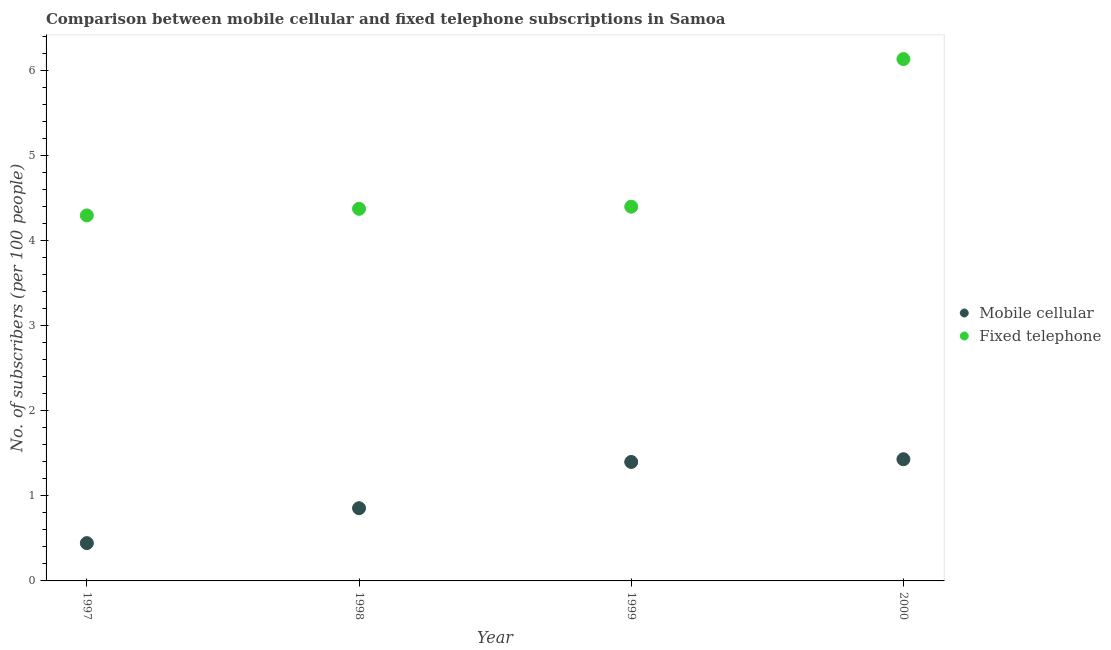What is the number of mobile cellular subscribers in 1998?
Offer a terse response. 0.86. Across all years, what is the maximum number of fixed telephone subscribers?
Your response must be concise. 6.14. Across all years, what is the minimum number of fixed telephone subscribers?
Provide a short and direct response. 4.3. What is the total number of mobile cellular subscribers in the graph?
Offer a very short reply. 4.13. What is the difference between the number of mobile cellular subscribers in 1999 and that in 2000?
Make the answer very short. -0.03. What is the difference between the number of fixed telephone subscribers in 1997 and the number of mobile cellular subscribers in 2000?
Provide a short and direct response. 2.87. What is the average number of fixed telephone subscribers per year?
Give a very brief answer. 4.81. In the year 1997, what is the difference between the number of mobile cellular subscribers and number of fixed telephone subscribers?
Offer a very short reply. -3.86. What is the ratio of the number of mobile cellular subscribers in 1997 to that in 1998?
Your response must be concise. 0.52. Is the number of fixed telephone subscribers in 1998 less than that in 1999?
Offer a very short reply. Yes. Is the difference between the number of mobile cellular subscribers in 1999 and 2000 greater than the difference between the number of fixed telephone subscribers in 1999 and 2000?
Your response must be concise. Yes. What is the difference between the highest and the second highest number of fixed telephone subscribers?
Your answer should be very brief. 1.74. What is the difference between the highest and the lowest number of mobile cellular subscribers?
Keep it short and to the point. 0.99. In how many years, is the number of mobile cellular subscribers greater than the average number of mobile cellular subscribers taken over all years?
Offer a very short reply. 2. How many dotlines are there?
Make the answer very short. 2. What is the difference between two consecutive major ticks on the Y-axis?
Make the answer very short. 1. Where does the legend appear in the graph?
Provide a short and direct response. Center right. How many legend labels are there?
Ensure brevity in your answer.  2. What is the title of the graph?
Your response must be concise. Comparison between mobile cellular and fixed telephone subscriptions in Samoa. What is the label or title of the Y-axis?
Your response must be concise. No. of subscribers (per 100 people). What is the No. of subscribers (per 100 people) of Mobile cellular in 1997?
Make the answer very short. 0.44. What is the No. of subscribers (per 100 people) in Fixed telephone in 1997?
Offer a terse response. 4.3. What is the No. of subscribers (per 100 people) in Mobile cellular in 1998?
Your response must be concise. 0.86. What is the No. of subscribers (per 100 people) of Fixed telephone in 1998?
Offer a very short reply. 4.38. What is the No. of subscribers (per 100 people) of Mobile cellular in 1999?
Your answer should be compact. 1.4. What is the No. of subscribers (per 100 people) of Fixed telephone in 1999?
Make the answer very short. 4.4. What is the No. of subscribers (per 100 people) of Mobile cellular in 2000?
Your answer should be compact. 1.43. What is the No. of subscribers (per 100 people) of Fixed telephone in 2000?
Ensure brevity in your answer.  6.14. Across all years, what is the maximum No. of subscribers (per 100 people) in Mobile cellular?
Provide a succinct answer. 1.43. Across all years, what is the maximum No. of subscribers (per 100 people) in Fixed telephone?
Give a very brief answer. 6.14. Across all years, what is the minimum No. of subscribers (per 100 people) in Mobile cellular?
Your response must be concise. 0.44. Across all years, what is the minimum No. of subscribers (per 100 people) of Fixed telephone?
Ensure brevity in your answer.  4.3. What is the total No. of subscribers (per 100 people) in Mobile cellular in the graph?
Provide a succinct answer. 4.13. What is the total No. of subscribers (per 100 people) in Fixed telephone in the graph?
Your answer should be very brief. 19.22. What is the difference between the No. of subscribers (per 100 people) in Mobile cellular in 1997 and that in 1998?
Ensure brevity in your answer.  -0.41. What is the difference between the No. of subscribers (per 100 people) in Fixed telephone in 1997 and that in 1998?
Make the answer very short. -0.08. What is the difference between the No. of subscribers (per 100 people) in Mobile cellular in 1997 and that in 1999?
Keep it short and to the point. -0.95. What is the difference between the No. of subscribers (per 100 people) in Fixed telephone in 1997 and that in 1999?
Offer a terse response. -0.1. What is the difference between the No. of subscribers (per 100 people) in Mobile cellular in 1997 and that in 2000?
Make the answer very short. -0.99. What is the difference between the No. of subscribers (per 100 people) in Fixed telephone in 1997 and that in 2000?
Provide a short and direct response. -1.84. What is the difference between the No. of subscribers (per 100 people) of Mobile cellular in 1998 and that in 1999?
Your response must be concise. -0.54. What is the difference between the No. of subscribers (per 100 people) in Fixed telephone in 1998 and that in 1999?
Offer a very short reply. -0.02. What is the difference between the No. of subscribers (per 100 people) in Mobile cellular in 1998 and that in 2000?
Give a very brief answer. -0.58. What is the difference between the No. of subscribers (per 100 people) of Fixed telephone in 1998 and that in 2000?
Keep it short and to the point. -1.76. What is the difference between the No. of subscribers (per 100 people) of Mobile cellular in 1999 and that in 2000?
Your answer should be very brief. -0.03. What is the difference between the No. of subscribers (per 100 people) of Fixed telephone in 1999 and that in 2000?
Give a very brief answer. -1.74. What is the difference between the No. of subscribers (per 100 people) of Mobile cellular in 1997 and the No. of subscribers (per 100 people) of Fixed telephone in 1998?
Your response must be concise. -3.93. What is the difference between the No. of subscribers (per 100 people) in Mobile cellular in 1997 and the No. of subscribers (per 100 people) in Fixed telephone in 1999?
Your answer should be very brief. -3.96. What is the difference between the No. of subscribers (per 100 people) in Mobile cellular in 1997 and the No. of subscribers (per 100 people) in Fixed telephone in 2000?
Keep it short and to the point. -5.69. What is the difference between the No. of subscribers (per 100 people) in Mobile cellular in 1998 and the No. of subscribers (per 100 people) in Fixed telephone in 1999?
Provide a succinct answer. -3.55. What is the difference between the No. of subscribers (per 100 people) in Mobile cellular in 1998 and the No. of subscribers (per 100 people) in Fixed telephone in 2000?
Give a very brief answer. -5.28. What is the difference between the No. of subscribers (per 100 people) of Mobile cellular in 1999 and the No. of subscribers (per 100 people) of Fixed telephone in 2000?
Offer a very short reply. -4.74. What is the average No. of subscribers (per 100 people) in Mobile cellular per year?
Provide a short and direct response. 1.03. What is the average No. of subscribers (per 100 people) of Fixed telephone per year?
Provide a short and direct response. 4.81. In the year 1997, what is the difference between the No. of subscribers (per 100 people) in Mobile cellular and No. of subscribers (per 100 people) in Fixed telephone?
Keep it short and to the point. -3.86. In the year 1998, what is the difference between the No. of subscribers (per 100 people) of Mobile cellular and No. of subscribers (per 100 people) of Fixed telephone?
Provide a short and direct response. -3.52. In the year 1999, what is the difference between the No. of subscribers (per 100 people) in Mobile cellular and No. of subscribers (per 100 people) in Fixed telephone?
Provide a short and direct response. -3. In the year 2000, what is the difference between the No. of subscribers (per 100 people) in Mobile cellular and No. of subscribers (per 100 people) in Fixed telephone?
Provide a short and direct response. -4.71. What is the ratio of the No. of subscribers (per 100 people) in Mobile cellular in 1997 to that in 1998?
Offer a terse response. 0.52. What is the ratio of the No. of subscribers (per 100 people) of Fixed telephone in 1997 to that in 1998?
Give a very brief answer. 0.98. What is the ratio of the No. of subscribers (per 100 people) of Mobile cellular in 1997 to that in 1999?
Offer a terse response. 0.32. What is the ratio of the No. of subscribers (per 100 people) in Fixed telephone in 1997 to that in 1999?
Give a very brief answer. 0.98. What is the ratio of the No. of subscribers (per 100 people) in Mobile cellular in 1997 to that in 2000?
Offer a terse response. 0.31. What is the ratio of the No. of subscribers (per 100 people) in Fixed telephone in 1997 to that in 2000?
Offer a very short reply. 0.7. What is the ratio of the No. of subscribers (per 100 people) of Mobile cellular in 1998 to that in 1999?
Offer a terse response. 0.61. What is the ratio of the No. of subscribers (per 100 people) in Fixed telephone in 1998 to that in 1999?
Your response must be concise. 0.99. What is the ratio of the No. of subscribers (per 100 people) in Mobile cellular in 1998 to that in 2000?
Your answer should be compact. 0.6. What is the ratio of the No. of subscribers (per 100 people) of Fixed telephone in 1998 to that in 2000?
Give a very brief answer. 0.71. What is the ratio of the No. of subscribers (per 100 people) in Mobile cellular in 1999 to that in 2000?
Give a very brief answer. 0.98. What is the ratio of the No. of subscribers (per 100 people) of Fixed telephone in 1999 to that in 2000?
Your answer should be compact. 0.72. What is the difference between the highest and the second highest No. of subscribers (per 100 people) in Mobile cellular?
Your response must be concise. 0.03. What is the difference between the highest and the second highest No. of subscribers (per 100 people) of Fixed telephone?
Your response must be concise. 1.74. What is the difference between the highest and the lowest No. of subscribers (per 100 people) of Mobile cellular?
Keep it short and to the point. 0.99. What is the difference between the highest and the lowest No. of subscribers (per 100 people) in Fixed telephone?
Your answer should be very brief. 1.84. 